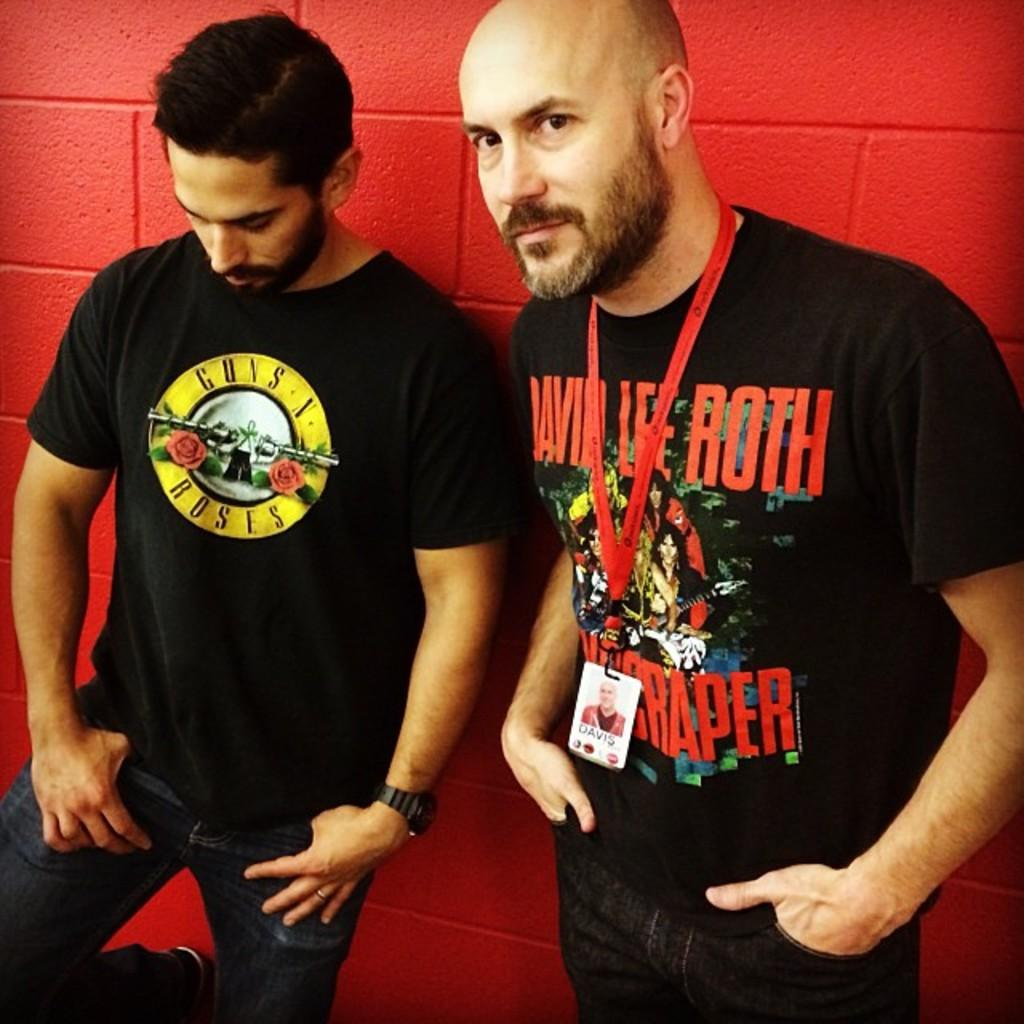<image>
Describe the image concisely. A man in a Guns N Roses t-shirt standing next to another man. 